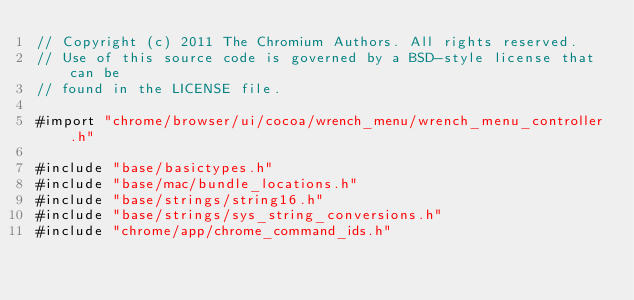<code> <loc_0><loc_0><loc_500><loc_500><_ObjectiveC_>// Copyright (c) 2011 The Chromium Authors. All rights reserved.
// Use of this source code is governed by a BSD-style license that can be
// found in the LICENSE file.

#import "chrome/browser/ui/cocoa/wrench_menu/wrench_menu_controller.h"

#include "base/basictypes.h"
#include "base/mac/bundle_locations.h"
#include "base/strings/string16.h"
#include "base/strings/sys_string_conversions.h"
#include "chrome/app/chrome_command_ids.h"</code> 